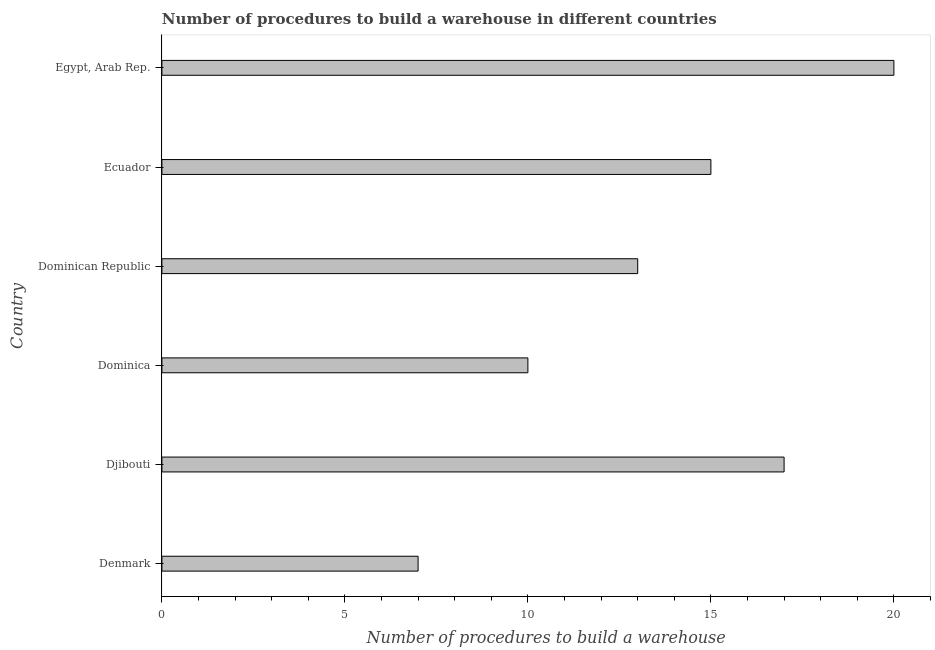Does the graph contain any zero values?
Your response must be concise. No. Does the graph contain grids?
Ensure brevity in your answer.  No. What is the title of the graph?
Make the answer very short. Number of procedures to build a warehouse in different countries. What is the label or title of the X-axis?
Ensure brevity in your answer.  Number of procedures to build a warehouse. What is the number of procedures to build a warehouse in Dominican Republic?
Your answer should be compact. 13. Across all countries, what is the maximum number of procedures to build a warehouse?
Offer a very short reply. 20. Across all countries, what is the minimum number of procedures to build a warehouse?
Provide a succinct answer. 7. In which country was the number of procedures to build a warehouse maximum?
Make the answer very short. Egypt, Arab Rep. In which country was the number of procedures to build a warehouse minimum?
Offer a terse response. Denmark. What is the sum of the number of procedures to build a warehouse?
Ensure brevity in your answer.  82. What is the difference between the number of procedures to build a warehouse in Denmark and Dominican Republic?
Provide a succinct answer. -6. What is the average number of procedures to build a warehouse per country?
Provide a succinct answer. 13.67. What is the median number of procedures to build a warehouse?
Provide a short and direct response. 14. What is the ratio of the number of procedures to build a warehouse in Djibouti to that in Ecuador?
Make the answer very short. 1.13. Is the number of procedures to build a warehouse in Dominica less than that in Egypt, Arab Rep.?
Your answer should be very brief. Yes. Is the difference between the number of procedures to build a warehouse in Djibouti and Ecuador greater than the difference between any two countries?
Keep it short and to the point. No. In how many countries, is the number of procedures to build a warehouse greater than the average number of procedures to build a warehouse taken over all countries?
Make the answer very short. 3. How many bars are there?
Provide a succinct answer. 6. Are all the bars in the graph horizontal?
Give a very brief answer. Yes. How many countries are there in the graph?
Ensure brevity in your answer.  6. What is the Number of procedures to build a warehouse of Denmark?
Offer a very short reply. 7. What is the Number of procedures to build a warehouse in Djibouti?
Provide a short and direct response. 17. What is the Number of procedures to build a warehouse of Dominica?
Offer a terse response. 10. What is the Number of procedures to build a warehouse in Ecuador?
Provide a short and direct response. 15. What is the difference between the Number of procedures to build a warehouse in Denmark and Djibouti?
Your answer should be compact. -10. What is the difference between the Number of procedures to build a warehouse in Denmark and Dominican Republic?
Ensure brevity in your answer.  -6. What is the difference between the Number of procedures to build a warehouse in Djibouti and Dominican Republic?
Your answer should be compact. 4. What is the difference between the Number of procedures to build a warehouse in Djibouti and Ecuador?
Provide a succinct answer. 2. What is the difference between the Number of procedures to build a warehouse in Dominica and Dominican Republic?
Provide a short and direct response. -3. What is the difference between the Number of procedures to build a warehouse in Dominica and Ecuador?
Offer a very short reply. -5. What is the difference between the Number of procedures to build a warehouse in Dominica and Egypt, Arab Rep.?
Give a very brief answer. -10. What is the difference between the Number of procedures to build a warehouse in Dominican Republic and Ecuador?
Your answer should be very brief. -2. What is the ratio of the Number of procedures to build a warehouse in Denmark to that in Djibouti?
Offer a terse response. 0.41. What is the ratio of the Number of procedures to build a warehouse in Denmark to that in Dominican Republic?
Ensure brevity in your answer.  0.54. What is the ratio of the Number of procedures to build a warehouse in Denmark to that in Ecuador?
Provide a succinct answer. 0.47. What is the ratio of the Number of procedures to build a warehouse in Djibouti to that in Dominican Republic?
Offer a very short reply. 1.31. What is the ratio of the Number of procedures to build a warehouse in Djibouti to that in Ecuador?
Provide a short and direct response. 1.13. What is the ratio of the Number of procedures to build a warehouse in Djibouti to that in Egypt, Arab Rep.?
Give a very brief answer. 0.85. What is the ratio of the Number of procedures to build a warehouse in Dominica to that in Dominican Republic?
Provide a succinct answer. 0.77. What is the ratio of the Number of procedures to build a warehouse in Dominica to that in Ecuador?
Give a very brief answer. 0.67. What is the ratio of the Number of procedures to build a warehouse in Dominican Republic to that in Ecuador?
Your answer should be compact. 0.87. What is the ratio of the Number of procedures to build a warehouse in Dominican Republic to that in Egypt, Arab Rep.?
Give a very brief answer. 0.65. What is the ratio of the Number of procedures to build a warehouse in Ecuador to that in Egypt, Arab Rep.?
Offer a very short reply. 0.75. 